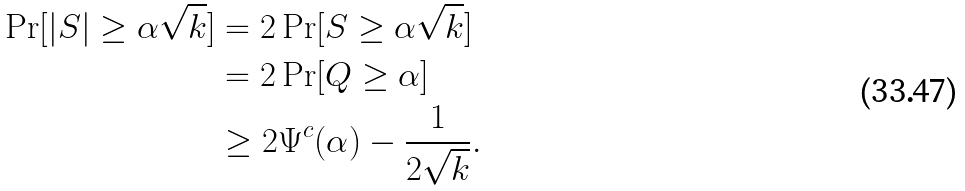Convert formula to latex. <formula><loc_0><loc_0><loc_500><loc_500>\Pr [ | S | \geq \alpha \sqrt { k } ] & = 2 \Pr [ S \geq \alpha \sqrt { k } ] \\ & = 2 \Pr [ Q \geq \alpha ] \\ & \geq 2 \Psi ^ { c } ( \alpha ) - \frac { 1 } { 2 \sqrt { k } } .</formula> 